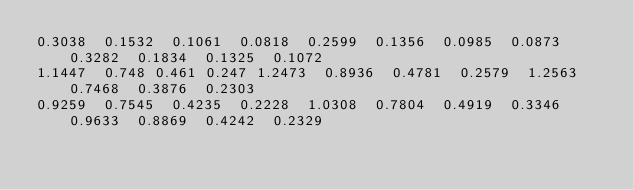<code> <loc_0><loc_0><loc_500><loc_500><_SQL_>0.3038	0.1532	0.1061	0.0818	0.2599	0.1356	0.0985	0.0873	0.3282	0.1834	0.1325	0.1072
1.1447	0.748	0.461	0.247	1.2473	0.8936	0.4781	0.2579	1.2563	0.7468	0.3876	0.2303
0.9259	0.7545	0.4235	0.2228	1.0308	0.7804	0.4919	0.3346	0.9633	0.8869	0.4242	0.2329
</code> 